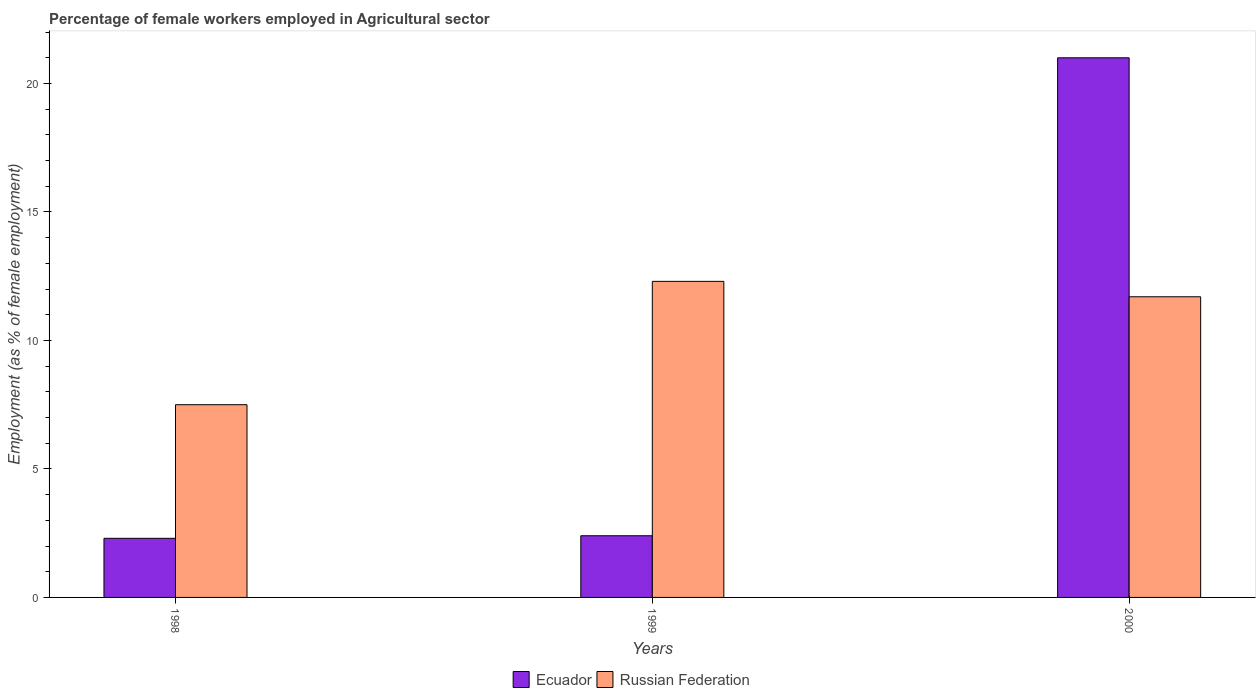How many groups of bars are there?
Provide a short and direct response. 3. Are the number of bars on each tick of the X-axis equal?
Provide a short and direct response. Yes. How many bars are there on the 1st tick from the right?
Offer a very short reply. 2. What is the label of the 2nd group of bars from the left?
Give a very brief answer. 1999. What is the percentage of females employed in Agricultural sector in Ecuador in 1998?
Give a very brief answer. 2.3. Across all years, what is the maximum percentage of females employed in Agricultural sector in Ecuador?
Make the answer very short. 21. In which year was the percentage of females employed in Agricultural sector in Russian Federation minimum?
Provide a succinct answer. 1998. What is the total percentage of females employed in Agricultural sector in Russian Federation in the graph?
Provide a short and direct response. 31.5. What is the difference between the percentage of females employed in Agricultural sector in Russian Federation in 1998 and that in 1999?
Your answer should be very brief. -4.8. What is the difference between the percentage of females employed in Agricultural sector in Russian Federation in 2000 and the percentage of females employed in Agricultural sector in Ecuador in 1999?
Your response must be concise. 9.3. In the year 1999, what is the difference between the percentage of females employed in Agricultural sector in Ecuador and percentage of females employed in Agricultural sector in Russian Federation?
Provide a short and direct response. -9.9. What is the ratio of the percentage of females employed in Agricultural sector in Russian Federation in 1999 to that in 2000?
Offer a very short reply. 1.05. Is the percentage of females employed in Agricultural sector in Ecuador in 1998 less than that in 1999?
Provide a short and direct response. Yes. What is the difference between the highest and the second highest percentage of females employed in Agricultural sector in Ecuador?
Make the answer very short. 18.6. What is the difference between the highest and the lowest percentage of females employed in Agricultural sector in Russian Federation?
Offer a very short reply. 4.8. What does the 2nd bar from the left in 1998 represents?
Keep it short and to the point. Russian Federation. What does the 2nd bar from the right in 1999 represents?
Your answer should be very brief. Ecuador. Are all the bars in the graph horizontal?
Your answer should be very brief. No. How many years are there in the graph?
Provide a succinct answer. 3. What is the difference between two consecutive major ticks on the Y-axis?
Your answer should be very brief. 5. Are the values on the major ticks of Y-axis written in scientific E-notation?
Give a very brief answer. No. Does the graph contain any zero values?
Your answer should be compact. No. Does the graph contain grids?
Provide a short and direct response. No. Where does the legend appear in the graph?
Make the answer very short. Bottom center. How are the legend labels stacked?
Provide a succinct answer. Horizontal. What is the title of the graph?
Make the answer very short. Percentage of female workers employed in Agricultural sector. What is the label or title of the Y-axis?
Your response must be concise. Employment (as % of female employment). What is the Employment (as % of female employment) in Ecuador in 1998?
Keep it short and to the point. 2.3. What is the Employment (as % of female employment) in Russian Federation in 1998?
Provide a succinct answer. 7.5. What is the Employment (as % of female employment) of Ecuador in 1999?
Offer a very short reply. 2.4. What is the Employment (as % of female employment) in Russian Federation in 1999?
Provide a succinct answer. 12.3. What is the Employment (as % of female employment) in Ecuador in 2000?
Provide a short and direct response. 21. What is the Employment (as % of female employment) in Russian Federation in 2000?
Keep it short and to the point. 11.7. Across all years, what is the maximum Employment (as % of female employment) in Russian Federation?
Offer a very short reply. 12.3. Across all years, what is the minimum Employment (as % of female employment) in Ecuador?
Your answer should be compact. 2.3. Across all years, what is the minimum Employment (as % of female employment) of Russian Federation?
Provide a succinct answer. 7.5. What is the total Employment (as % of female employment) of Ecuador in the graph?
Your response must be concise. 25.7. What is the total Employment (as % of female employment) in Russian Federation in the graph?
Offer a very short reply. 31.5. What is the difference between the Employment (as % of female employment) of Russian Federation in 1998 and that in 1999?
Provide a short and direct response. -4.8. What is the difference between the Employment (as % of female employment) of Ecuador in 1998 and that in 2000?
Offer a terse response. -18.7. What is the difference between the Employment (as % of female employment) of Ecuador in 1999 and that in 2000?
Offer a terse response. -18.6. What is the difference between the Employment (as % of female employment) in Ecuador in 1998 and the Employment (as % of female employment) in Russian Federation in 1999?
Your response must be concise. -10. What is the average Employment (as % of female employment) of Ecuador per year?
Make the answer very short. 8.57. What is the average Employment (as % of female employment) in Russian Federation per year?
Make the answer very short. 10.5. In the year 1998, what is the difference between the Employment (as % of female employment) of Ecuador and Employment (as % of female employment) of Russian Federation?
Offer a terse response. -5.2. In the year 1999, what is the difference between the Employment (as % of female employment) in Ecuador and Employment (as % of female employment) in Russian Federation?
Provide a succinct answer. -9.9. In the year 2000, what is the difference between the Employment (as % of female employment) in Ecuador and Employment (as % of female employment) in Russian Federation?
Provide a short and direct response. 9.3. What is the ratio of the Employment (as % of female employment) of Russian Federation in 1998 to that in 1999?
Your answer should be very brief. 0.61. What is the ratio of the Employment (as % of female employment) of Ecuador in 1998 to that in 2000?
Give a very brief answer. 0.11. What is the ratio of the Employment (as % of female employment) in Russian Federation in 1998 to that in 2000?
Provide a succinct answer. 0.64. What is the ratio of the Employment (as % of female employment) of Ecuador in 1999 to that in 2000?
Offer a very short reply. 0.11. What is the ratio of the Employment (as % of female employment) in Russian Federation in 1999 to that in 2000?
Your answer should be compact. 1.05. What is the difference between the highest and the second highest Employment (as % of female employment) in Russian Federation?
Provide a short and direct response. 0.6. What is the difference between the highest and the lowest Employment (as % of female employment) in Russian Federation?
Ensure brevity in your answer.  4.8. 